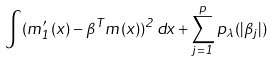<formula> <loc_0><loc_0><loc_500><loc_500>\int ( m ^ { \prime } _ { 1 } ( x ) - \beta ^ { T } m ( x ) ) ^ { 2 } \, d x + \sum _ { j = 1 } ^ { p } p _ { \lambda } ( | \beta _ { j } | )</formula> 